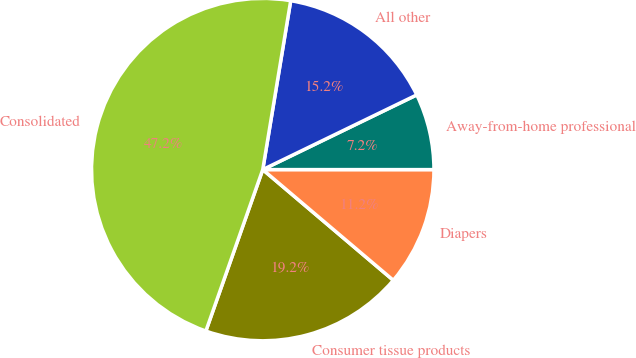Convert chart to OTSL. <chart><loc_0><loc_0><loc_500><loc_500><pie_chart><fcel>Consumer tissue products<fcel>Diapers<fcel>Away-from-home professional<fcel>All other<fcel>Consolidated<nl><fcel>19.2%<fcel>11.19%<fcel>7.19%<fcel>15.2%<fcel>47.22%<nl></chart> 